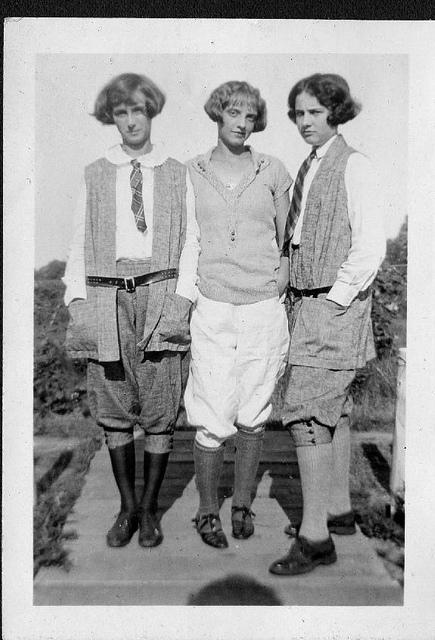Are they about to go skiing?
Short answer required. No. What country is this person from?
Quick response, please. England. Is this a Polaroid picture?
Quick response, please. No. How many people are here?
Keep it brief. 3. Where is the cap?
Short answer required. Nowhere. Where are they staring?
Quick response, please. Camera. How many women are pictured?
Short answer required. 3. How many baseball gloves are showing?
Give a very brief answer. 0. What color pants is the person in the middle wearing?
Give a very brief answer. White. How many are looking at the camera?
Keep it brief. 3. How many people are sitting down?
Be succinct. 0. Are the people men or women?
Be succinct. Women. Are their shorts really short?
Short answer required. No. Are the men wearing ties?
Be succinct. Yes. How many men are there?
Be succinct. 0. How are the women in the pictures feeling?
Quick response, please. Happy. 